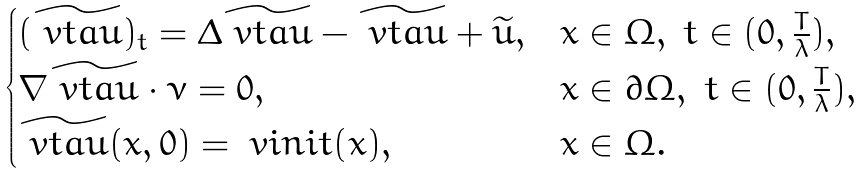<formula> <loc_0><loc_0><loc_500><loc_500>\begin{cases} ( \widetilde { \ v t a u } ) _ { t } = \Delta \widetilde { \ v t a u } - \widetilde { \ v t a u } + \widetilde { u } , & x \in \Omega , \ t \in ( 0 , \frac { T } { \lambda } ) , \\ \nabla \widetilde { \ v t a u } \cdot \nu = 0 , & x \in \partial \Omega , \ t \in ( 0 , \frac { T } { \lambda } ) , \\ \widetilde { \ v t a u } ( x , 0 ) = \ v i n i t ( x ) , & x \in \Omega . \end{cases}</formula> 